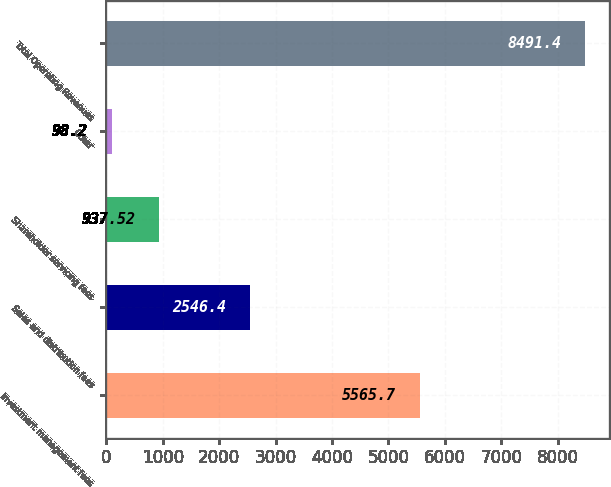Convert chart. <chart><loc_0><loc_0><loc_500><loc_500><bar_chart><fcel>Investment management fees<fcel>Sales and distribution fees<fcel>Shareholder servicing fees<fcel>Other<fcel>Total Operating Revenues<nl><fcel>5565.7<fcel>2546.4<fcel>937.52<fcel>98.2<fcel>8491.4<nl></chart> 